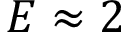<formula> <loc_0><loc_0><loc_500><loc_500>E \approx 2</formula> 